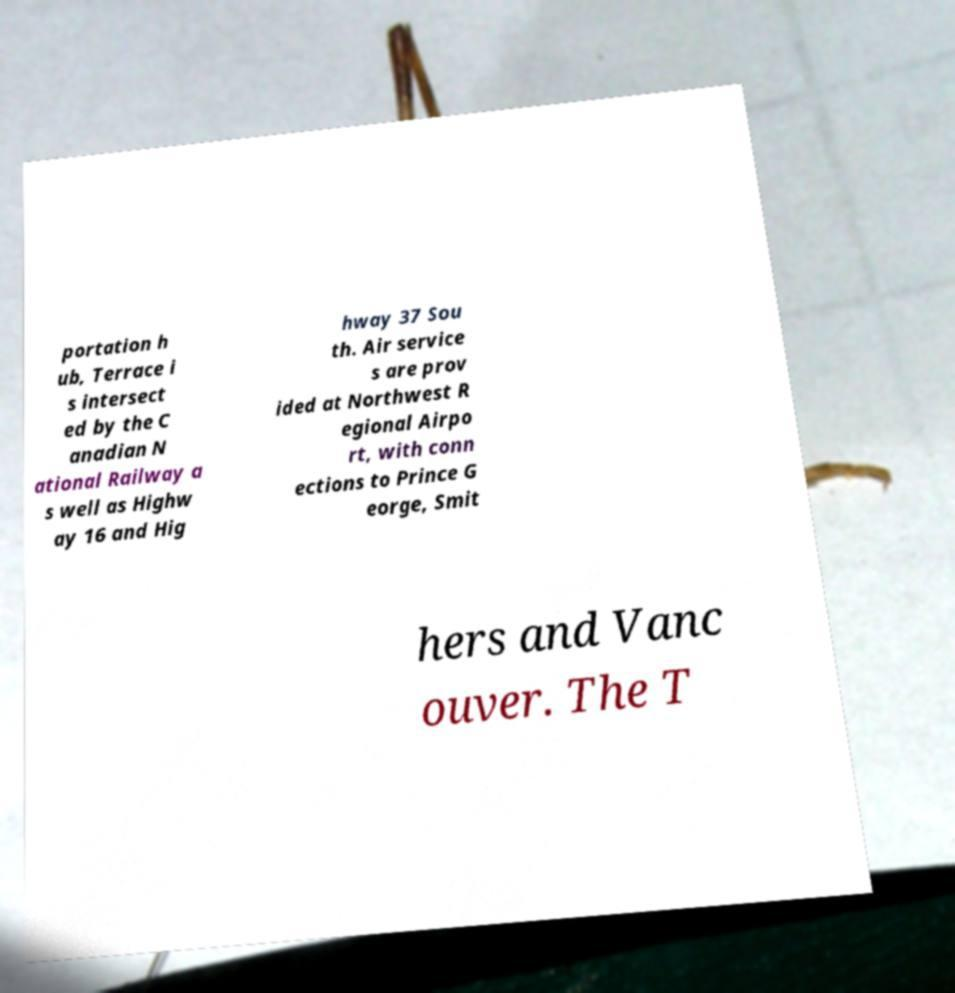For documentation purposes, I need the text within this image transcribed. Could you provide that? portation h ub, Terrace i s intersect ed by the C anadian N ational Railway a s well as Highw ay 16 and Hig hway 37 Sou th. Air service s are prov ided at Northwest R egional Airpo rt, with conn ections to Prince G eorge, Smit hers and Vanc ouver. The T 